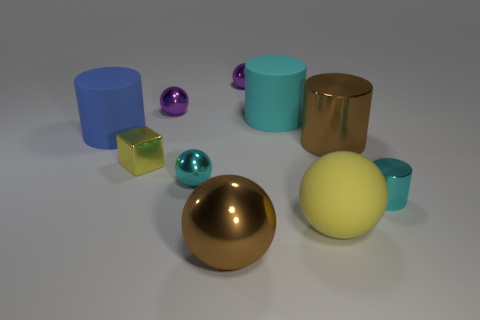There is a big thing that is behind the blue cylinder; is its shape the same as the large yellow object?
Give a very brief answer. No. There is a large ball that is the same color as the block; what is it made of?
Give a very brief answer. Rubber. What number of tiny blocks have the same color as the rubber ball?
Your response must be concise. 1. What shape is the big brown thing that is in front of the tiny ball that is in front of the blue thing?
Your answer should be compact. Sphere. Is there a tiny metallic thing that has the same shape as the cyan rubber thing?
Provide a short and direct response. Yes. There is a tiny cylinder; is it the same color as the metal ball in front of the big yellow ball?
Offer a very short reply. No. There is a rubber object that is the same color as the tiny cylinder; what size is it?
Your answer should be compact. Large. Are there any purple things of the same size as the yellow matte object?
Offer a very short reply. No. Do the large blue cylinder and the ball that is to the left of the cyan ball have the same material?
Give a very brief answer. No. Are there more blue spheres than large brown metal cylinders?
Your answer should be very brief. No. 